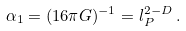<formula> <loc_0><loc_0><loc_500><loc_500>\alpha _ { 1 } = ( 1 6 \pi G ) ^ { - 1 } = l _ { P } ^ { 2 - D } \, .</formula> 